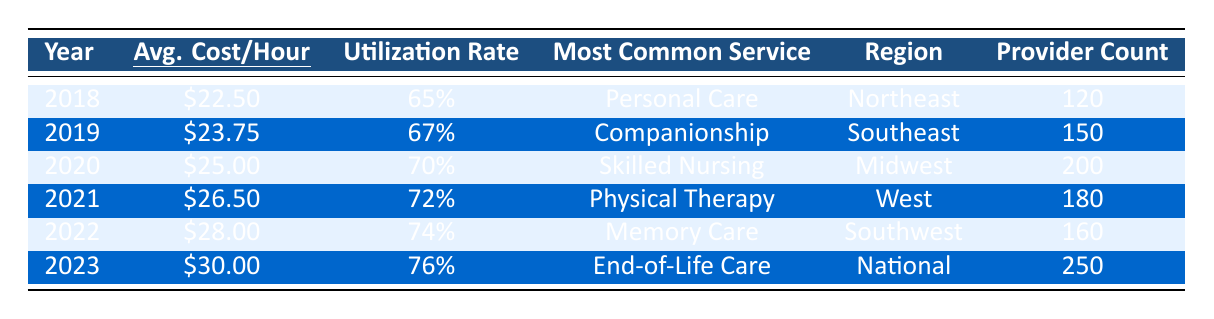What was the average cost per hour for in-home care services in 2020? The average cost per hour listed for the year 2020 in the table is \$25.00.
Answer: \$25.00 What was the utilization rate in 2019? The utilization rate for the year 2019 is provided in the table as 67%.
Answer: 67% Which year had the most common service listed as "Physical Therapy"? According to the table, "Physical Therapy" was the most common service in the year 2021.
Answer: 2021 How much did the average cost per hour increase from 2018 to 2023? The average cost in 2018 was \$22.50, and in 2023 it was \$30.00. The difference is \$30.00 - \$22.50 = \$7.50.
Answer: \$7.50 What is the total number of providers counted from 2018 to 2023? Summing the provider counts: 120 + 150 + 200 + 180 + 160 + 250 = 1060.
Answer: 1060 Was the utilization rate highest in 2021? The highest utilization rate in the table is 76% in 2023; thus, 2021 did not have the highest rate.
Answer: No Which region had the highest provider count in 2023? The provider count for 2023 is 250, which occurred in the National region, making it the highest.
Answer: National What is the average cost per hour for the years 2018 to 2022? To find the average, sum the costs: \$22.50 + \$23.75 + \$25.00 + \$26.50 + \$28.00 = \$125.75, then divide by 5 years: \$125.75 / 5 = \$25.15.
Answer: \$25.15 How many years had a utilization rate of 70% or higher? The years with utilization rates of 70% or higher (2020, 2021, 2022, 2023) total to four years.
Answer: 4 Which service was most common in 2018? The table indicates that "Personal Care" was the most common service in 2018.
Answer: Personal Care What was the percentage increase in the average cost per hour from 2020 to 2023? The average cost in 2020 is \$25.00, and in 2023 it is \$30.00. The increase is \$30.00 - \$25.00 = \$5.00. The percentage increase is (\$5.00 / \$25.00) * 100 = 20%.
Answer: 20% 